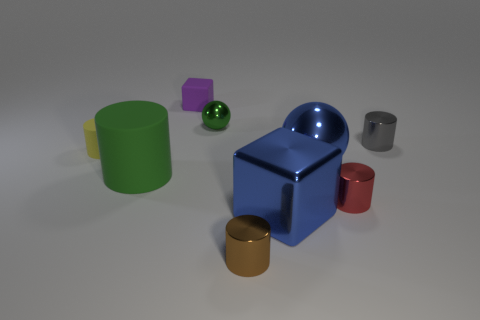Subtract all brown cylinders. How many cylinders are left? 4 Add 1 big gray cubes. How many objects exist? 10 Subtract all green cylinders. How many cylinders are left? 4 Add 6 tiny brown cylinders. How many tiny brown cylinders exist? 7 Subtract 0 brown blocks. How many objects are left? 9 Subtract all balls. How many objects are left? 7 Subtract 2 cubes. How many cubes are left? 0 Subtract all green balls. Subtract all blue blocks. How many balls are left? 1 Subtract all large cylinders. Subtract all green shiny objects. How many objects are left? 7 Add 6 large cylinders. How many large cylinders are left? 7 